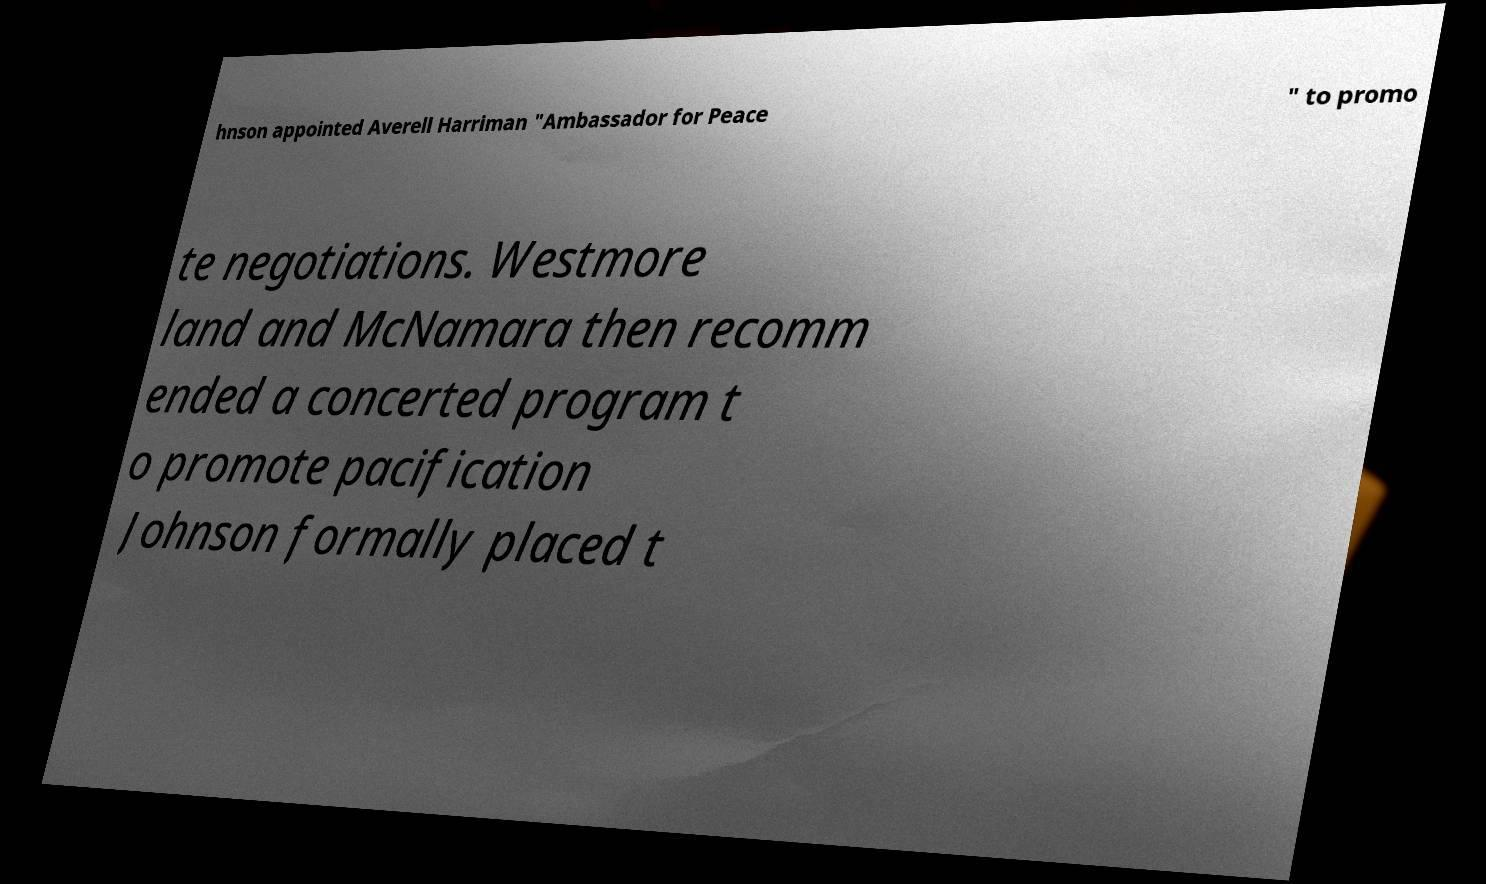For documentation purposes, I need the text within this image transcribed. Could you provide that? hnson appointed Averell Harriman "Ambassador for Peace " to promo te negotiations. Westmore land and McNamara then recomm ended a concerted program t o promote pacification Johnson formally placed t 